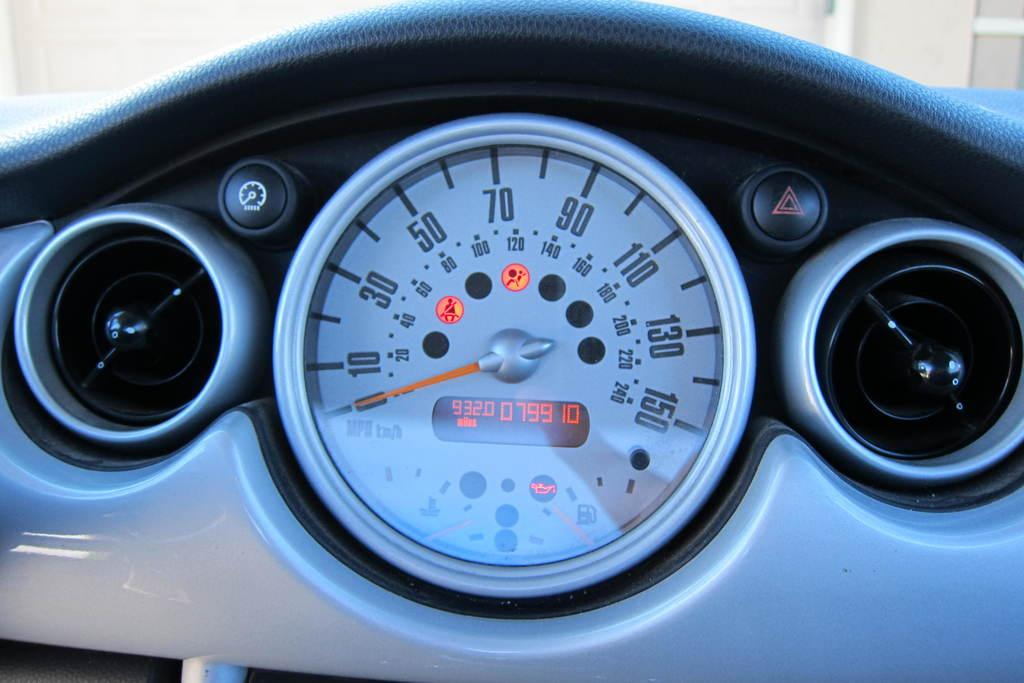What type of device is the speedometer in the image part of? The speedometer is likely part of a vehicle's dashboard. What other features can be seen on the vehicle's dashboard in the image? There are buttons visible in the image, which are likely part of the vehicle's dashboard. What type of sock is being used to adjust the speedometer in the image? There is no sock present in the image, and the speedometer is not being adjusted. 